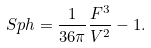Convert formula to latex. <formula><loc_0><loc_0><loc_500><loc_500>S p h = \frac { 1 } { 3 6 \pi } \frac { F ^ { 3 } } { V ^ { 2 } } - 1 .</formula> 